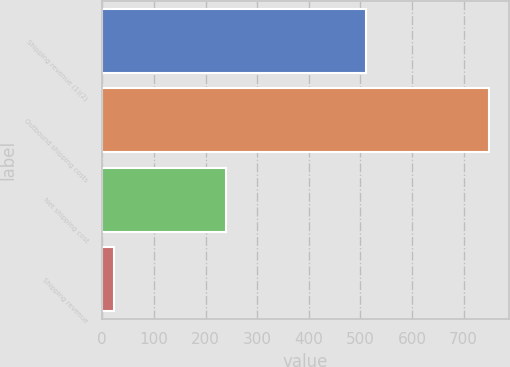Convert chart. <chart><loc_0><loc_0><loc_500><loc_500><bar_chart><fcel>Shipping revenue (1)(2)<fcel>Outbound shipping costs<fcel>Net shipping cost<fcel>Shipping revenue<nl><fcel>511<fcel>750<fcel>239<fcel>22<nl></chart> 